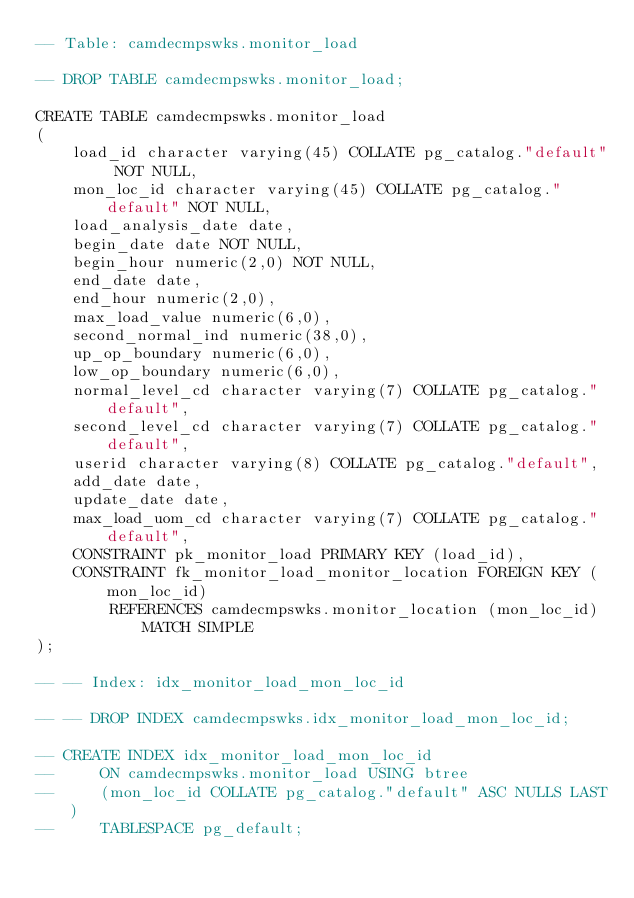<code> <loc_0><loc_0><loc_500><loc_500><_SQL_>-- Table: camdecmpswks.monitor_load

-- DROP TABLE camdecmpswks.monitor_load;

CREATE TABLE camdecmpswks.monitor_load
(
    load_id character varying(45) COLLATE pg_catalog."default" NOT NULL,
    mon_loc_id character varying(45) COLLATE pg_catalog."default" NOT NULL,
    load_analysis_date date,
    begin_date date NOT NULL,
    begin_hour numeric(2,0) NOT NULL,
    end_date date,
    end_hour numeric(2,0),
    max_load_value numeric(6,0),
    second_normal_ind numeric(38,0),
    up_op_boundary numeric(6,0),
    low_op_boundary numeric(6,0),
    normal_level_cd character varying(7) COLLATE pg_catalog."default",
    second_level_cd character varying(7) COLLATE pg_catalog."default",
    userid character varying(8) COLLATE pg_catalog."default",
    add_date date,
    update_date date,
    max_load_uom_cd character varying(7) COLLATE pg_catalog."default",
    CONSTRAINT pk_monitor_load PRIMARY KEY (load_id),
    CONSTRAINT fk_monitor_load_monitor_location FOREIGN KEY (mon_loc_id)
        REFERENCES camdecmpswks.monitor_location (mon_loc_id) MATCH SIMPLE
);

-- -- Index: idx_monitor_load_mon_loc_id

-- -- DROP INDEX camdecmpswks.idx_monitor_load_mon_loc_id;

-- CREATE INDEX idx_monitor_load_mon_loc_id
--     ON camdecmpswks.monitor_load USING btree
--     (mon_loc_id COLLATE pg_catalog."default" ASC NULLS LAST)
--     TABLESPACE pg_default;</code> 